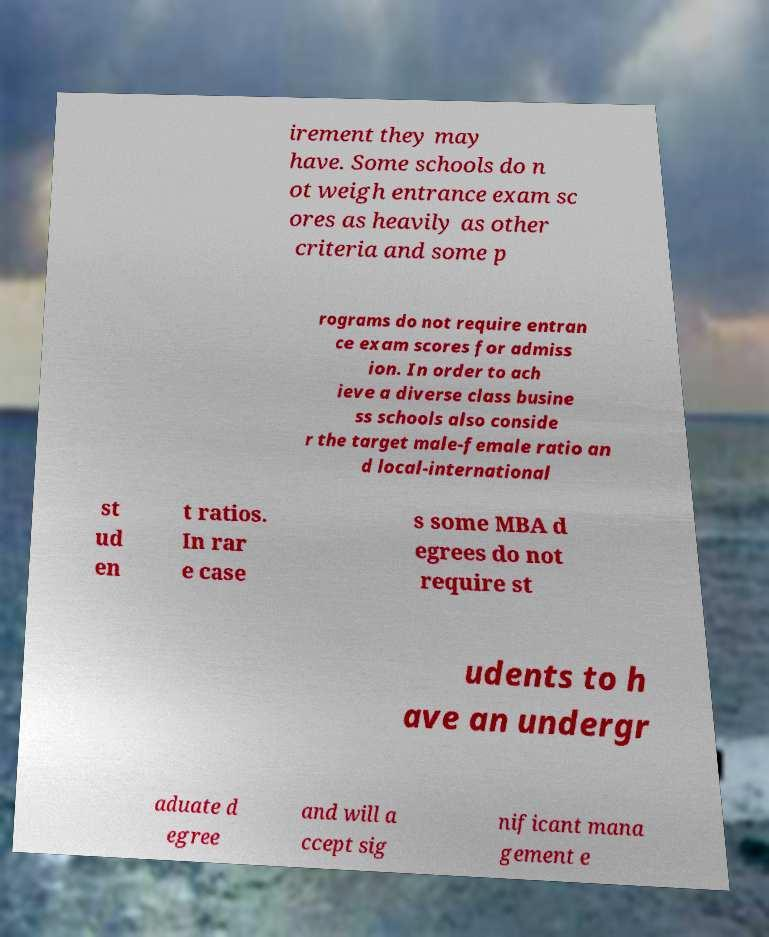Could you extract and type out the text from this image? irement they may have. Some schools do n ot weigh entrance exam sc ores as heavily as other criteria and some p rograms do not require entran ce exam scores for admiss ion. In order to ach ieve a diverse class busine ss schools also conside r the target male-female ratio an d local-international st ud en t ratios. In rar e case s some MBA d egrees do not require st udents to h ave an undergr aduate d egree and will a ccept sig nificant mana gement e 